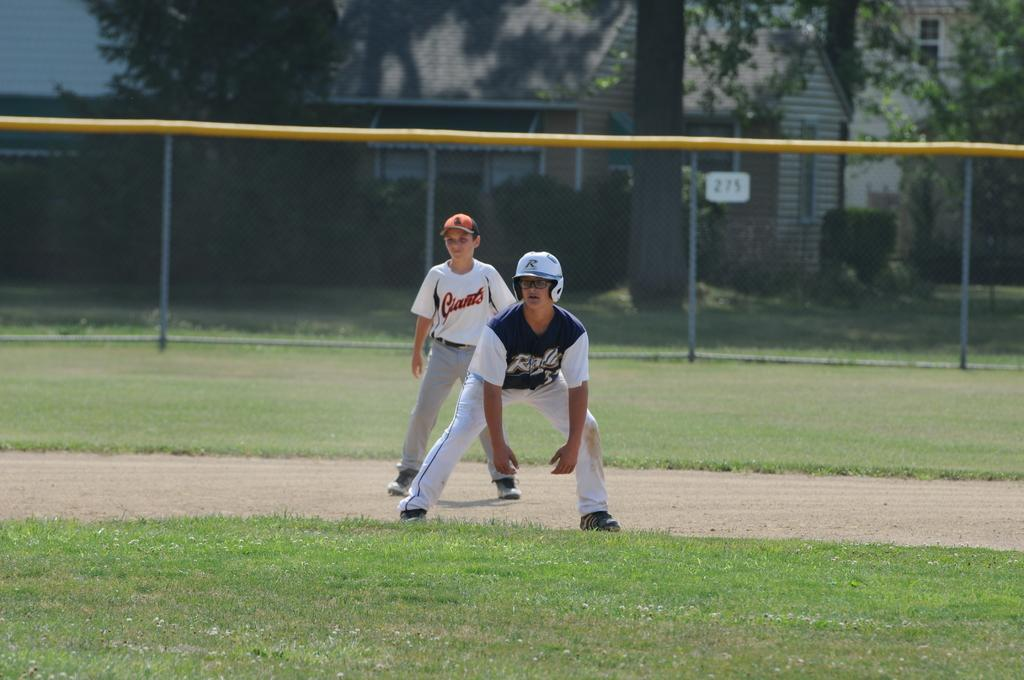<image>
Render a clear and concise summary of the photo. a boy in a Giants jersey stands behind another baseball player on a base 